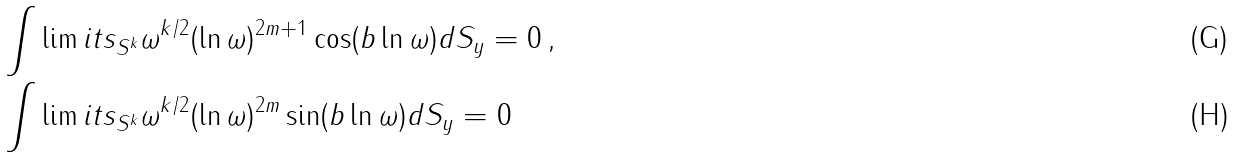<formula> <loc_0><loc_0><loc_500><loc_500>& \int \lim i t s _ { S ^ { k } } \omega ^ { k / 2 } ( \ln \omega ) ^ { 2 m + 1 } \cos ( b \ln \omega ) d S _ { y } = 0 \, , \\ & \int \lim i t s _ { S ^ { k } } \omega ^ { k / 2 } ( \ln \omega ) ^ { 2 m } \sin ( b \ln \omega ) d S _ { y } = 0</formula> 